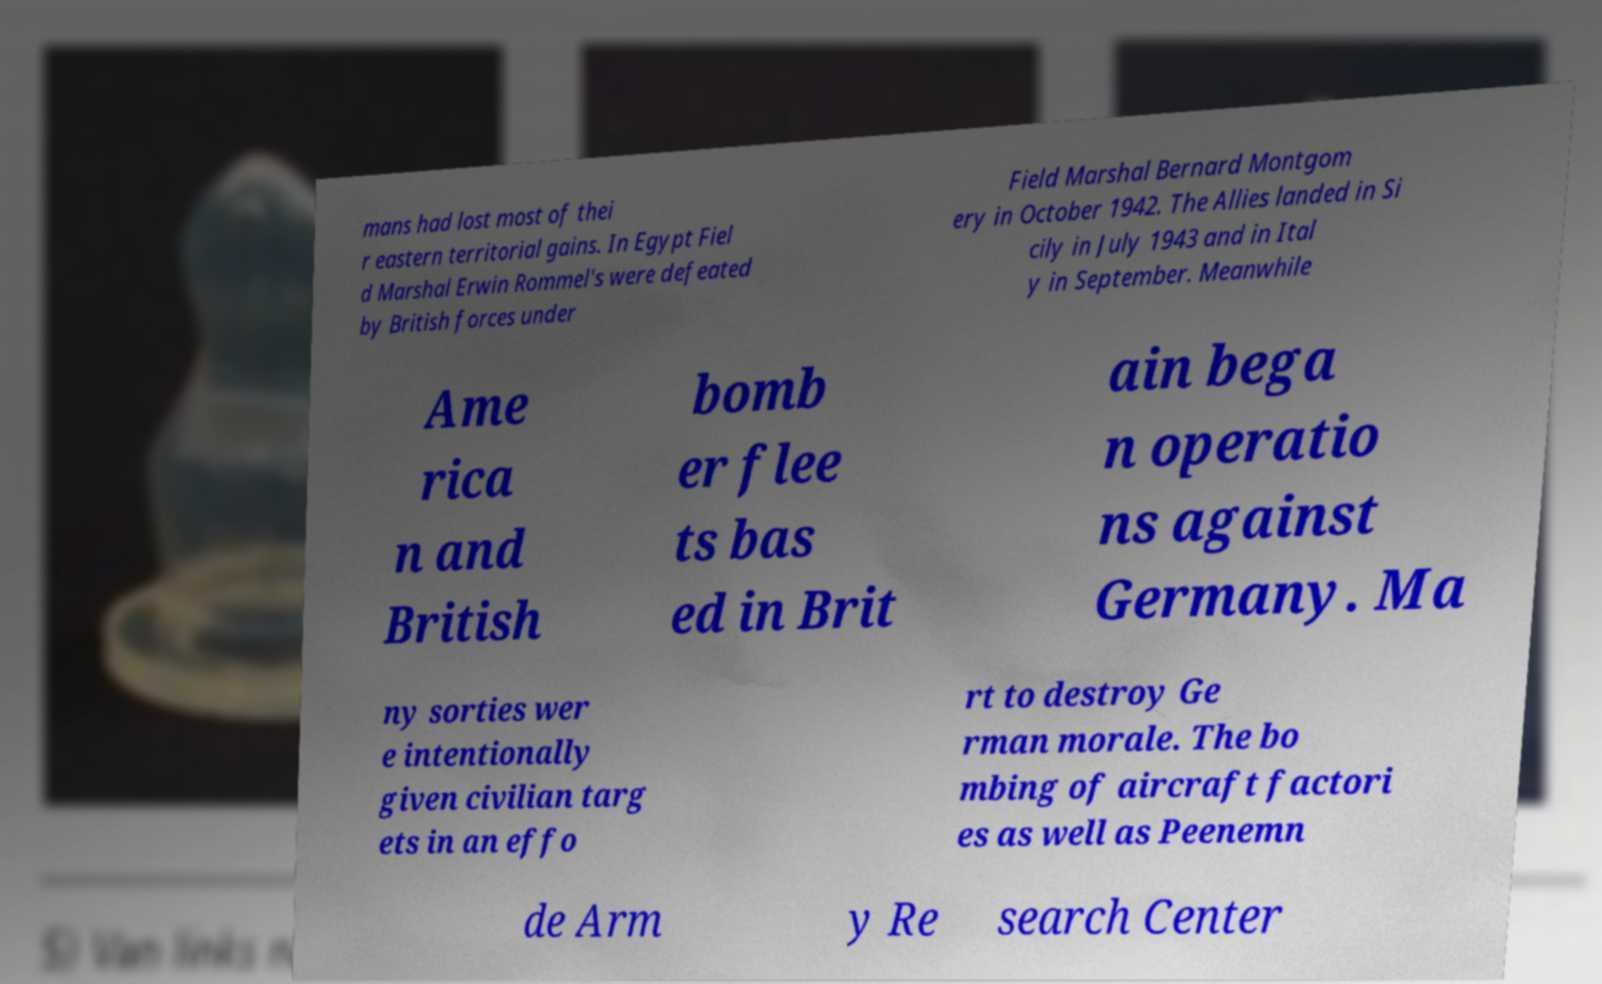Please identify and transcribe the text found in this image. mans had lost most of thei r eastern territorial gains. In Egypt Fiel d Marshal Erwin Rommel's were defeated by British forces under Field Marshal Bernard Montgom ery in October 1942. The Allies landed in Si cily in July 1943 and in Ital y in September. Meanwhile Ame rica n and British bomb er flee ts bas ed in Brit ain bega n operatio ns against Germany. Ma ny sorties wer e intentionally given civilian targ ets in an effo rt to destroy Ge rman morale. The bo mbing of aircraft factori es as well as Peenemn de Arm y Re search Center 